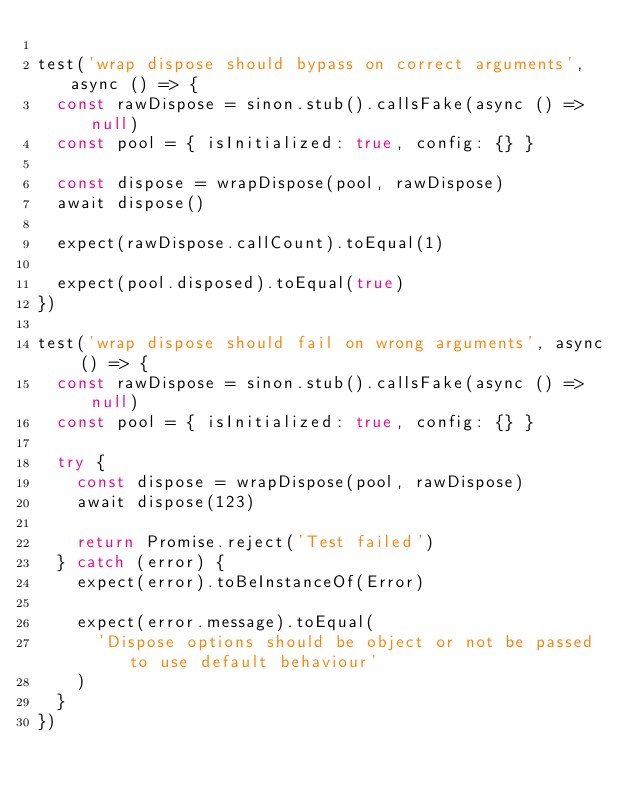Convert code to text. <code><loc_0><loc_0><loc_500><loc_500><_JavaScript_>
test('wrap dispose should bypass on correct arguments', async () => {
  const rawDispose = sinon.stub().callsFake(async () => null)
  const pool = { isInitialized: true, config: {} }

  const dispose = wrapDispose(pool, rawDispose)
  await dispose()

  expect(rawDispose.callCount).toEqual(1)

  expect(pool.disposed).toEqual(true)
})

test('wrap dispose should fail on wrong arguments', async () => {
  const rawDispose = sinon.stub().callsFake(async () => null)
  const pool = { isInitialized: true, config: {} }

  try {
    const dispose = wrapDispose(pool, rawDispose)
    await dispose(123)

    return Promise.reject('Test failed')
  } catch (error) {
    expect(error).toBeInstanceOf(Error)

    expect(error.message).toEqual(
      'Dispose options should be object or not be passed to use default behaviour'
    )
  }
})
</code> 